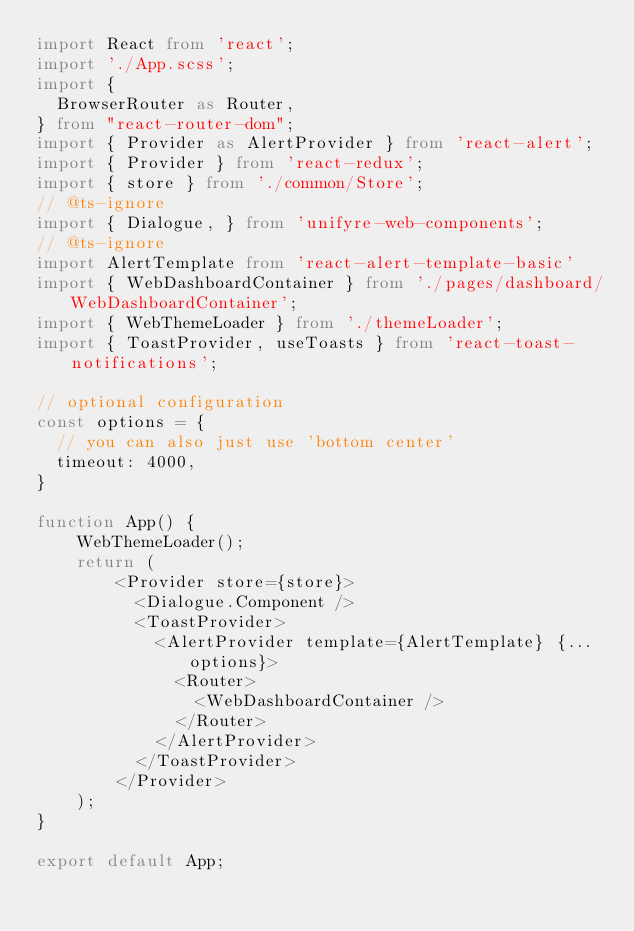Convert code to text. <code><loc_0><loc_0><loc_500><loc_500><_TypeScript_>import React from 'react';
import './App.scss';
import {
  BrowserRouter as Router,
} from "react-router-dom";
import { Provider as AlertProvider } from 'react-alert';
import { Provider } from 'react-redux';
import { store } from './common/Store';
// @ts-ignore
import { Dialogue, } from 'unifyre-web-components';
// @ts-ignore
import AlertTemplate from 'react-alert-template-basic'
import { WebDashboardContainer } from './pages/dashboard/WebDashboardContainer';
import { WebThemeLoader } from './themeLoader';
import { ToastProvider, useToasts } from 'react-toast-notifications';

// optional configuration
const options = {
  // you can also just use 'bottom center'
  timeout: 4000,
}

function App() {
    WebThemeLoader();
    return (
        <Provider store={store}>
          <Dialogue.Component />
          <ToastProvider>
            <AlertProvider template={AlertTemplate} {...options}>
              <Router>
                <WebDashboardContainer />
              </Router>
            </AlertProvider>
          </ToastProvider>
        </Provider>
    );  
}

export default App;
</code> 